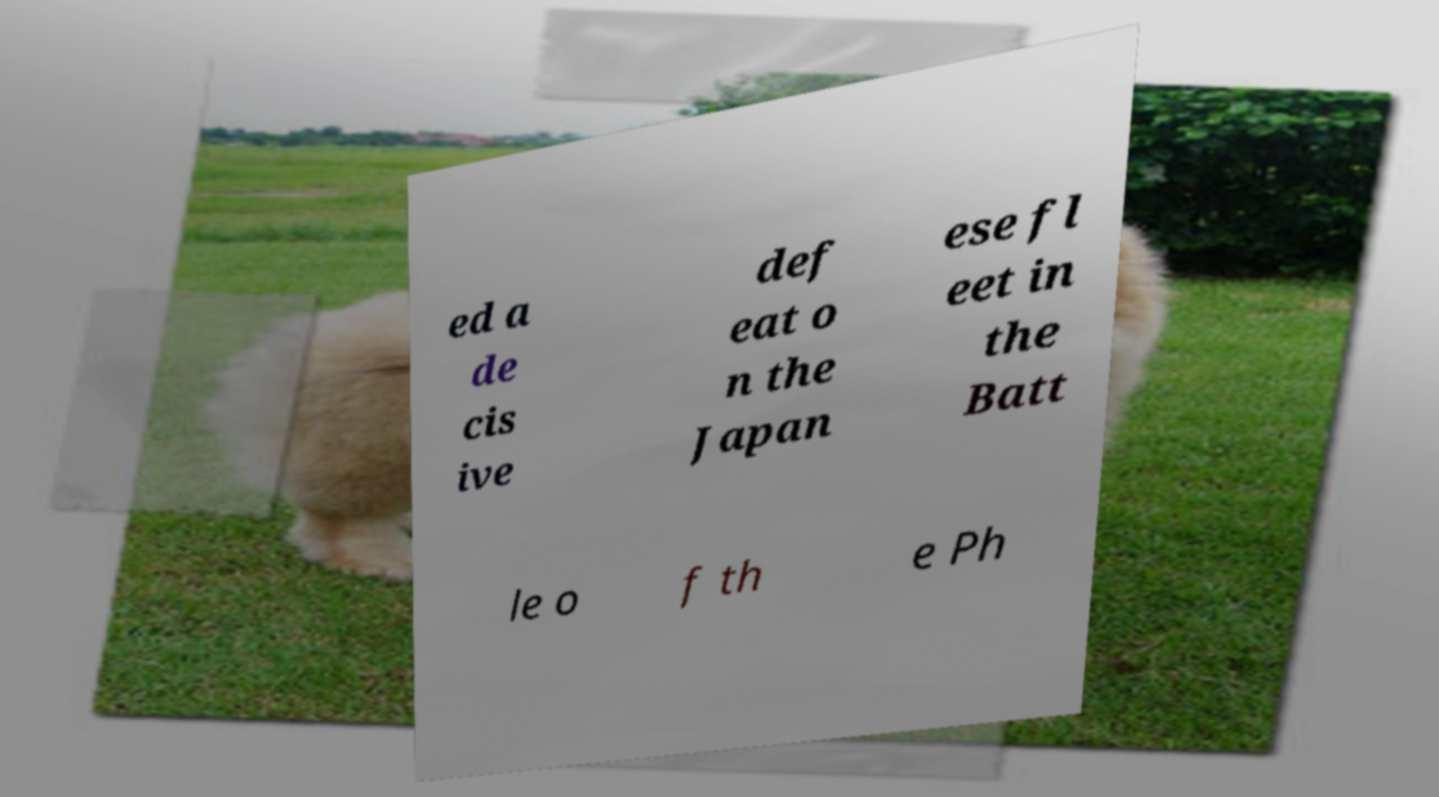I need the written content from this picture converted into text. Can you do that? ed a de cis ive def eat o n the Japan ese fl eet in the Batt le o f th e Ph 